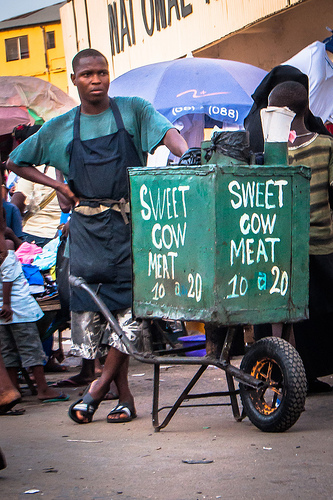<image>
Is the man under the umbrella? No. The man is not positioned under the umbrella. The vertical relationship between these objects is different. Is the meat can on the cart? Yes. Looking at the image, I can see the meat can is positioned on top of the cart, with the cart providing support. Is there a cow on the box? Yes. Looking at the image, I can see the cow is positioned on top of the box, with the box providing support. 